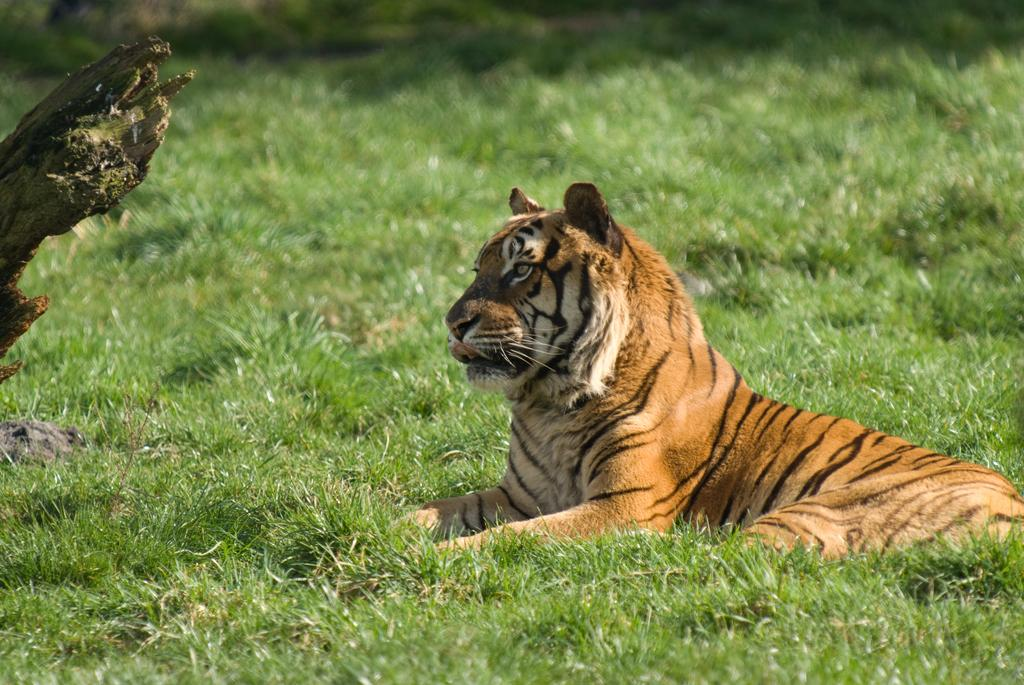What animal is the main subject of the picture? There is a tiger in the picture. What is the tiger's position in the image? The tiger is sitting on the grass. In which direction is the tiger looking? The tiger is looking in a particular direction. What note is the tiger playing on the hole in the image? There is no note or hole present in the image; it features a tiger sitting on the grass. 